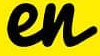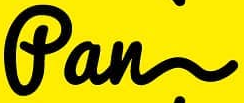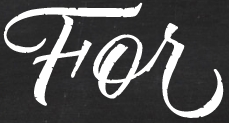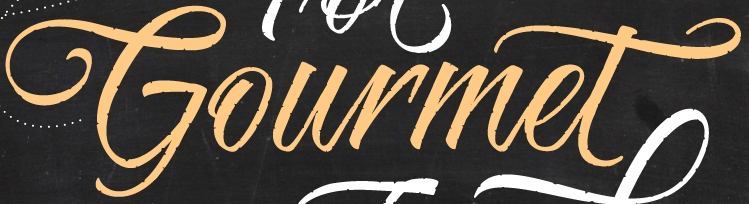Read the text content from these images in order, separated by a semicolon. en; fan; For; Gourmet 